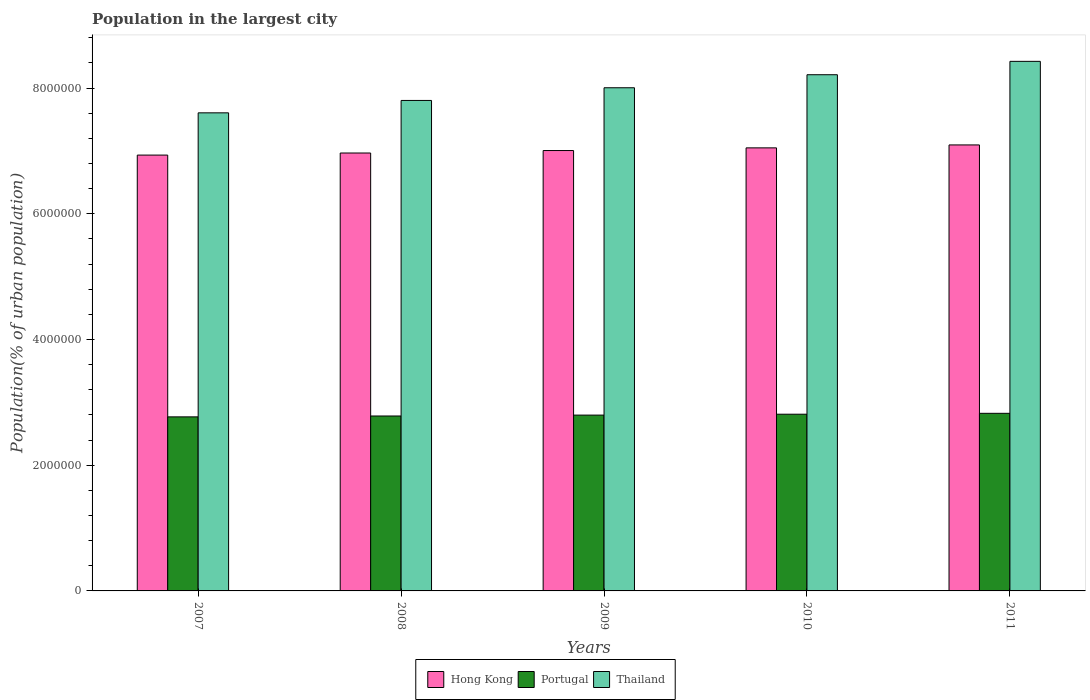Are the number of bars on each tick of the X-axis equal?
Ensure brevity in your answer.  Yes. How many bars are there on the 3rd tick from the left?
Keep it short and to the point. 3. How many bars are there on the 3rd tick from the right?
Offer a terse response. 3. In how many cases, is the number of bars for a given year not equal to the number of legend labels?
Your answer should be compact. 0. What is the population in the largest city in Portugal in 2007?
Your answer should be very brief. 2.77e+06. Across all years, what is the maximum population in the largest city in Thailand?
Your response must be concise. 8.43e+06. Across all years, what is the minimum population in the largest city in Hong Kong?
Ensure brevity in your answer.  6.93e+06. What is the total population in the largest city in Thailand in the graph?
Your answer should be compact. 4.01e+07. What is the difference between the population in the largest city in Hong Kong in 2008 and that in 2011?
Your answer should be compact. -1.28e+05. What is the difference between the population in the largest city in Thailand in 2011 and the population in the largest city in Hong Kong in 2008?
Your answer should be very brief. 1.46e+06. What is the average population in the largest city in Thailand per year?
Offer a very short reply. 8.01e+06. In the year 2008, what is the difference between the population in the largest city in Thailand and population in the largest city in Hong Kong?
Provide a short and direct response. 8.36e+05. What is the ratio of the population in the largest city in Thailand in 2009 to that in 2011?
Ensure brevity in your answer.  0.95. Is the difference between the population in the largest city in Thailand in 2010 and 2011 greater than the difference between the population in the largest city in Hong Kong in 2010 and 2011?
Give a very brief answer. No. What is the difference between the highest and the second highest population in the largest city in Portugal?
Provide a succinct answer. 1.42e+04. What is the difference between the highest and the lowest population in the largest city in Portugal?
Provide a short and direct response. 5.64e+04. Is the sum of the population in the largest city in Hong Kong in 2007 and 2011 greater than the maximum population in the largest city in Portugal across all years?
Offer a very short reply. Yes. What does the 3rd bar from the left in 2011 represents?
Keep it short and to the point. Thailand. What does the 1st bar from the right in 2009 represents?
Your answer should be compact. Thailand. How many bars are there?
Your response must be concise. 15. How many years are there in the graph?
Make the answer very short. 5. What is the difference between two consecutive major ticks on the Y-axis?
Give a very brief answer. 2.00e+06. How many legend labels are there?
Keep it short and to the point. 3. How are the legend labels stacked?
Ensure brevity in your answer.  Horizontal. What is the title of the graph?
Your response must be concise. Population in the largest city. Does "Equatorial Guinea" appear as one of the legend labels in the graph?
Your response must be concise. No. What is the label or title of the X-axis?
Keep it short and to the point. Years. What is the label or title of the Y-axis?
Provide a succinct answer. Population(% of urban population). What is the Population(% of urban population) of Hong Kong in 2007?
Keep it short and to the point. 6.93e+06. What is the Population(% of urban population) of Portugal in 2007?
Offer a terse response. 2.77e+06. What is the Population(% of urban population) of Thailand in 2007?
Your response must be concise. 7.61e+06. What is the Population(% of urban population) in Hong Kong in 2008?
Provide a short and direct response. 6.97e+06. What is the Population(% of urban population) of Portugal in 2008?
Give a very brief answer. 2.78e+06. What is the Population(% of urban population) in Thailand in 2008?
Your answer should be very brief. 7.80e+06. What is the Population(% of urban population) in Hong Kong in 2009?
Your answer should be very brief. 7.01e+06. What is the Population(% of urban population) in Portugal in 2009?
Provide a succinct answer. 2.80e+06. What is the Population(% of urban population) of Thailand in 2009?
Give a very brief answer. 8.01e+06. What is the Population(% of urban population) in Hong Kong in 2010?
Provide a short and direct response. 7.05e+06. What is the Population(% of urban population) of Portugal in 2010?
Make the answer very short. 2.81e+06. What is the Population(% of urban population) of Thailand in 2010?
Provide a short and direct response. 8.21e+06. What is the Population(% of urban population) of Hong Kong in 2011?
Give a very brief answer. 7.10e+06. What is the Population(% of urban population) of Portugal in 2011?
Ensure brevity in your answer.  2.83e+06. What is the Population(% of urban population) in Thailand in 2011?
Make the answer very short. 8.43e+06. Across all years, what is the maximum Population(% of urban population) of Hong Kong?
Your answer should be very brief. 7.10e+06. Across all years, what is the maximum Population(% of urban population) in Portugal?
Ensure brevity in your answer.  2.83e+06. Across all years, what is the maximum Population(% of urban population) of Thailand?
Make the answer very short. 8.43e+06. Across all years, what is the minimum Population(% of urban population) of Hong Kong?
Provide a succinct answer. 6.93e+06. Across all years, what is the minimum Population(% of urban population) in Portugal?
Make the answer very short. 2.77e+06. Across all years, what is the minimum Population(% of urban population) of Thailand?
Provide a short and direct response. 7.61e+06. What is the total Population(% of urban population) in Hong Kong in the graph?
Provide a succinct answer. 3.51e+07. What is the total Population(% of urban population) in Portugal in the graph?
Give a very brief answer. 1.40e+07. What is the total Population(% of urban population) of Thailand in the graph?
Your answer should be very brief. 4.01e+07. What is the difference between the Population(% of urban population) of Hong Kong in 2007 and that in 2008?
Offer a very short reply. -3.31e+04. What is the difference between the Population(% of urban population) in Portugal in 2007 and that in 2008?
Keep it short and to the point. -1.40e+04. What is the difference between the Population(% of urban population) in Thailand in 2007 and that in 2008?
Your response must be concise. -1.97e+05. What is the difference between the Population(% of urban population) of Hong Kong in 2007 and that in 2009?
Provide a short and direct response. -7.22e+04. What is the difference between the Population(% of urban population) in Portugal in 2007 and that in 2009?
Provide a succinct answer. -2.81e+04. What is the difference between the Population(% of urban population) of Thailand in 2007 and that in 2009?
Keep it short and to the point. -3.99e+05. What is the difference between the Population(% of urban population) of Hong Kong in 2007 and that in 2010?
Keep it short and to the point. -1.15e+05. What is the difference between the Population(% of urban population) of Portugal in 2007 and that in 2010?
Give a very brief answer. -4.22e+04. What is the difference between the Population(% of urban population) in Thailand in 2007 and that in 2010?
Your answer should be very brief. -6.06e+05. What is the difference between the Population(% of urban population) in Hong Kong in 2007 and that in 2011?
Keep it short and to the point. -1.62e+05. What is the difference between the Population(% of urban population) in Portugal in 2007 and that in 2011?
Offer a terse response. -5.64e+04. What is the difference between the Population(% of urban population) in Thailand in 2007 and that in 2011?
Offer a very short reply. -8.19e+05. What is the difference between the Population(% of urban population) of Hong Kong in 2008 and that in 2009?
Keep it short and to the point. -3.91e+04. What is the difference between the Population(% of urban population) in Portugal in 2008 and that in 2009?
Provide a short and direct response. -1.41e+04. What is the difference between the Population(% of urban population) of Thailand in 2008 and that in 2009?
Offer a terse response. -2.02e+05. What is the difference between the Population(% of urban population) of Hong Kong in 2008 and that in 2010?
Keep it short and to the point. -8.16e+04. What is the difference between the Population(% of urban population) in Portugal in 2008 and that in 2010?
Give a very brief answer. -2.82e+04. What is the difference between the Population(% of urban population) of Thailand in 2008 and that in 2010?
Give a very brief answer. -4.09e+05. What is the difference between the Population(% of urban population) in Hong Kong in 2008 and that in 2011?
Ensure brevity in your answer.  -1.28e+05. What is the difference between the Population(% of urban population) of Portugal in 2008 and that in 2011?
Give a very brief answer. -4.24e+04. What is the difference between the Population(% of urban population) of Thailand in 2008 and that in 2011?
Provide a short and direct response. -6.22e+05. What is the difference between the Population(% of urban population) in Hong Kong in 2009 and that in 2010?
Keep it short and to the point. -4.26e+04. What is the difference between the Population(% of urban population) of Portugal in 2009 and that in 2010?
Provide a short and direct response. -1.41e+04. What is the difference between the Population(% of urban population) in Thailand in 2009 and that in 2010?
Offer a very short reply. -2.07e+05. What is the difference between the Population(% of urban population) of Hong Kong in 2009 and that in 2011?
Your answer should be compact. -8.94e+04. What is the difference between the Population(% of urban population) in Portugal in 2009 and that in 2011?
Provide a short and direct response. -2.84e+04. What is the difference between the Population(% of urban population) of Thailand in 2009 and that in 2011?
Offer a terse response. -4.20e+05. What is the difference between the Population(% of urban population) of Hong Kong in 2010 and that in 2011?
Provide a succinct answer. -4.68e+04. What is the difference between the Population(% of urban population) of Portugal in 2010 and that in 2011?
Your answer should be very brief. -1.42e+04. What is the difference between the Population(% of urban population) in Thailand in 2010 and that in 2011?
Keep it short and to the point. -2.13e+05. What is the difference between the Population(% of urban population) of Hong Kong in 2007 and the Population(% of urban population) of Portugal in 2008?
Offer a very short reply. 4.15e+06. What is the difference between the Population(% of urban population) in Hong Kong in 2007 and the Population(% of urban population) in Thailand in 2008?
Keep it short and to the point. -8.69e+05. What is the difference between the Population(% of urban population) of Portugal in 2007 and the Population(% of urban population) of Thailand in 2008?
Provide a short and direct response. -5.03e+06. What is the difference between the Population(% of urban population) of Hong Kong in 2007 and the Population(% of urban population) of Portugal in 2009?
Provide a short and direct response. 4.14e+06. What is the difference between the Population(% of urban population) of Hong Kong in 2007 and the Population(% of urban population) of Thailand in 2009?
Make the answer very short. -1.07e+06. What is the difference between the Population(% of urban population) of Portugal in 2007 and the Population(% of urban population) of Thailand in 2009?
Offer a very short reply. -5.24e+06. What is the difference between the Population(% of urban population) of Hong Kong in 2007 and the Population(% of urban population) of Portugal in 2010?
Give a very brief answer. 4.12e+06. What is the difference between the Population(% of urban population) of Hong Kong in 2007 and the Population(% of urban population) of Thailand in 2010?
Provide a short and direct response. -1.28e+06. What is the difference between the Population(% of urban population) of Portugal in 2007 and the Population(% of urban population) of Thailand in 2010?
Offer a very short reply. -5.44e+06. What is the difference between the Population(% of urban population) of Hong Kong in 2007 and the Population(% of urban population) of Portugal in 2011?
Offer a terse response. 4.11e+06. What is the difference between the Population(% of urban population) of Hong Kong in 2007 and the Population(% of urban population) of Thailand in 2011?
Provide a succinct answer. -1.49e+06. What is the difference between the Population(% of urban population) of Portugal in 2007 and the Population(% of urban population) of Thailand in 2011?
Provide a succinct answer. -5.66e+06. What is the difference between the Population(% of urban population) of Hong Kong in 2008 and the Population(% of urban population) of Portugal in 2009?
Ensure brevity in your answer.  4.17e+06. What is the difference between the Population(% of urban population) in Hong Kong in 2008 and the Population(% of urban population) in Thailand in 2009?
Ensure brevity in your answer.  -1.04e+06. What is the difference between the Population(% of urban population) of Portugal in 2008 and the Population(% of urban population) of Thailand in 2009?
Keep it short and to the point. -5.22e+06. What is the difference between the Population(% of urban population) in Hong Kong in 2008 and the Population(% of urban population) in Portugal in 2010?
Your response must be concise. 4.16e+06. What is the difference between the Population(% of urban population) in Hong Kong in 2008 and the Population(% of urban population) in Thailand in 2010?
Provide a short and direct response. -1.25e+06. What is the difference between the Population(% of urban population) in Portugal in 2008 and the Population(% of urban population) in Thailand in 2010?
Give a very brief answer. -5.43e+06. What is the difference between the Population(% of urban population) of Hong Kong in 2008 and the Population(% of urban population) of Portugal in 2011?
Provide a succinct answer. 4.14e+06. What is the difference between the Population(% of urban population) of Hong Kong in 2008 and the Population(% of urban population) of Thailand in 2011?
Provide a succinct answer. -1.46e+06. What is the difference between the Population(% of urban population) in Portugal in 2008 and the Population(% of urban population) in Thailand in 2011?
Provide a short and direct response. -5.64e+06. What is the difference between the Population(% of urban population) in Hong Kong in 2009 and the Population(% of urban population) in Portugal in 2010?
Provide a succinct answer. 4.20e+06. What is the difference between the Population(% of urban population) in Hong Kong in 2009 and the Population(% of urban population) in Thailand in 2010?
Offer a terse response. -1.21e+06. What is the difference between the Population(% of urban population) of Portugal in 2009 and the Population(% of urban population) of Thailand in 2010?
Give a very brief answer. -5.42e+06. What is the difference between the Population(% of urban population) of Hong Kong in 2009 and the Population(% of urban population) of Portugal in 2011?
Provide a succinct answer. 4.18e+06. What is the difference between the Population(% of urban population) in Hong Kong in 2009 and the Population(% of urban population) in Thailand in 2011?
Your answer should be very brief. -1.42e+06. What is the difference between the Population(% of urban population) in Portugal in 2009 and the Population(% of urban population) in Thailand in 2011?
Give a very brief answer. -5.63e+06. What is the difference between the Population(% of urban population) of Hong Kong in 2010 and the Population(% of urban population) of Portugal in 2011?
Ensure brevity in your answer.  4.22e+06. What is the difference between the Population(% of urban population) of Hong Kong in 2010 and the Population(% of urban population) of Thailand in 2011?
Your response must be concise. -1.38e+06. What is the difference between the Population(% of urban population) of Portugal in 2010 and the Population(% of urban population) of Thailand in 2011?
Give a very brief answer. -5.61e+06. What is the average Population(% of urban population) in Hong Kong per year?
Provide a succinct answer. 7.01e+06. What is the average Population(% of urban population) in Portugal per year?
Your response must be concise. 2.80e+06. What is the average Population(% of urban population) in Thailand per year?
Ensure brevity in your answer.  8.01e+06. In the year 2007, what is the difference between the Population(% of urban population) in Hong Kong and Population(% of urban population) in Portugal?
Offer a terse response. 4.17e+06. In the year 2007, what is the difference between the Population(% of urban population) in Hong Kong and Population(% of urban population) in Thailand?
Provide a short and direct response. -6.72e+05. In the year 2007, what is the difference between the Population(% of urban population) in Portugal and Population(% of urban population) in Thailand?
Offer a terse response. -4.84e+06. In the year 2008, what is the difference between the Population(% of urban population) of Hong Kong and Population(% of urban population) of Portugal?
Ensure brevity in your answer.  4.18e+06. In the year 2008, what is the difference between the Population(% of urban population) in Hong Kong and Population(% of urban population) in Thailand?
Your response must be concise. -8.36e+05. In the year 2008, what is the difference between the Population(% of urban population) of Portugal and Population(% of urban population) of Thailand?
Provide a short and direct response. -5.02e+06. In the year 2009, what is the difference between the Population(% of urban population) of Hong Kong and Population(% of urban population) of Portugal?
Make the answer very short. 4.21e+06. In the year 2009, what is the difference between the Population(% of urban population) of Hong Kong and Population(% of urban population) of Thailand?
Give a very brief answer. -9.99e+05. In the year 2009, what is the difference between the Population(% of urban population) of Portugal and Population(% of urban population) of Thailand?
Offer a terse response. -5.21e+06. In the year 2010, what is the difference between the Population(% of urban population) in Hong Kong and Population(% of urban population) in Portugal?
Keep it short and to the point. 4.24e+06. In the year 2010, what is the difference between the Population(% of urban population) in Hong Kong and Population(% of urban population) in Thailand?
Offer a very short reply. -1.16e+06. In the year 2010, what is the difference between the Population(% of urban population) of Portugal and Population(% of urban population) of Thailand?
Your answer should be compact. -5.40e+06. In the year 2011, what is the difference between the Population(% of urban population) of Hong Kong and Population(% of urban population) of Portugal?
Your answer should be compact. 4.27e+06. In the year 2011, what is the difference between the Population(% of urban population) of Hong Kong and Population(% of urban population) of Thailand?
Offer a terse response. -1.33e+06. In the year 2011, what is the difference between the Population(% of urban population) of Portugal and Population(% of urban population) of Thailand?
Your answer should be compact. -5.60e+06. What is the ratio of the Population(% of urban population) in Hong Kong in 2007 to that in 2008?
Offer a terse response. 1. What is the ratio of the Population(% of urban population) in Portugal in 2007 to that in 2008?
Your response must be concise. 0.99. What is the ratio of the Population(% of urban population) of Thailand in 2007 to that in 2008?
Make the answer very short. 0.97. What is the ratio of the Population(% of urban population) of Hong Kong in 2007 to that in 2009?
Ensure brevity in your answer.  0.99. What is the ratio of the Population(% of urban population) of Portugal in 2007 to that in 2009?
Offer a terse response. 0.99. What is the ratio of the Population(% of urban population) in Thailand in 2007 to that in 2009?
Ensure brevity in your answer.  0.95. What is the ratio of the Population(% of urban population) in Hong Kong in 2007 to that in 2010?
Ensure brevity in your answer.  0.98. What is the ratio of the Population(% of urban population) in Thailand in 2007 to that in 2010?
Offer a terse response. 0.93. What is the ratio of the Population(% of urban population) in Hong Kong in 2007 to that in 2011?
Provide a succinct answer. 0.98. What is the ratio of the Population(% of urban population) of Portugal in 2007 to that in 2011?
Give a very brief answer. 0.98. What is the ratio of the Population(% of urban population) in Thailand in 2007 to that in 2011?
Keep it short and to the point. 0.9. What is the ratio of the Population(% of urban population) in Thailand in 2008 to that in 2009?
Provide a short and direct response. 0.97. What is the ratio of the Population(% of urban population) in Hong Kong in 2008 to that in 2010?
Your response must be concise. 0.99. What is the ratio of the Population(% of urban population) in Portugal in 2008 to that in 2010?
Make the answer very short. 0.99. What is the ratio of the Population(% of urban population) of Thailand in 2008 to that in 2010?
Make the answer very short. 0.95. What is the ratio of the Population(% of urban population) of Hong Kong in 2008 to that in 2011?
Offer a very short reply. 0.98. What is the ratio of the Population(% of urban population) of Thailand in 2008 to that in 2011?
Provide a short and direct response. 0.93. What is the ratio of the Population(% of urban population) in Thailand in 2009 to that in 2010?
Offer a terse response. 0.97. What is the ratio of the Population(% of urban population) of Hong Kong in 2009 to that in 2011?
Make the answer very short. 0.99. What is the ratio of the Population(% of urban population) of Thailand in 2009 to that in 2011?
Provide a succinct answer. 0.95. What is the ratio of the Population(% of urban population) of Hong Kong in 2010 to that in 2011?
Make the answer very short. 0.99. What is the ratio of the Population(% of urban population) in Thailand in 2010 to that in 2011?
Offer a very short reply. 0.97. What is the difference between the highest and the second highest Population(% of urban population) of Hong Kong?
Provide a succinct answer. 4.68e+04. What is the difference between the highest and the second highest Population(% of urban population) in Portugal?
Make the answer very short. 1.42e+04. What is the difference between the highest and the second highest Population(% of urban population) of Thailand?
Your response must be concise. 2.13e+05. What is the difference between the highest and the lowest Population(% of urban population) of Hong Kong?
Make the answer very short. 1.62e+05. What is the difference between the highest and the lowest Population(% of urban population) in Portugal?
Your answer should be very brief. 5.64e+04. What is the difference between the highest and the lowest Population(% of urban population) in Thailand?
Provide a short and direct response. 8.19e+05. 